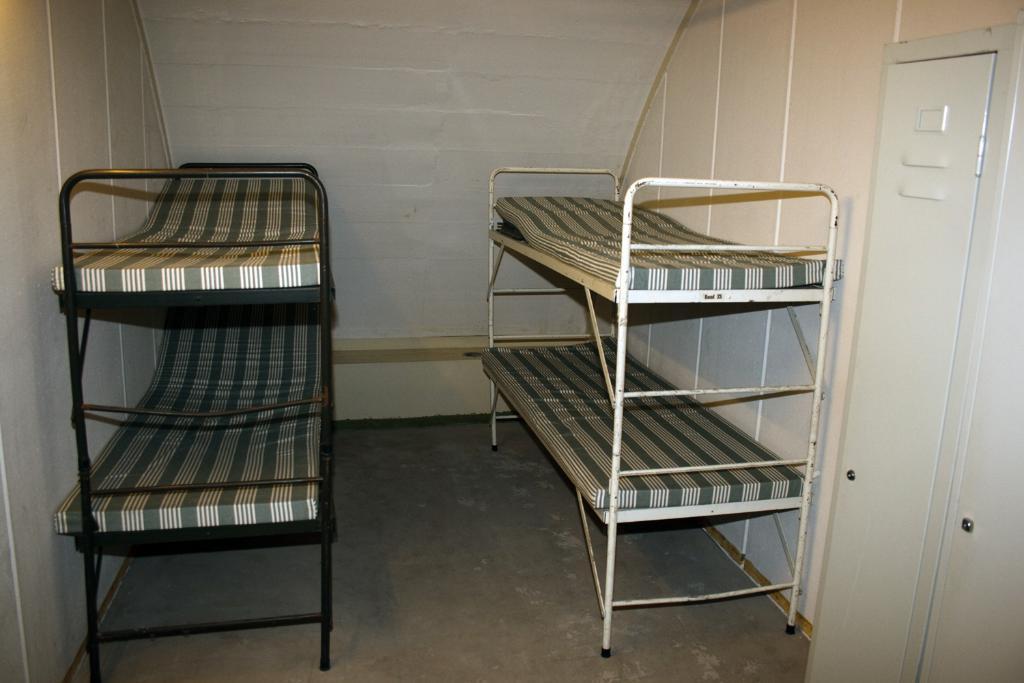Describe this image in one or two sentences. This picture is taken inside the room. In this image, on the right side, we can see a white color door and a bed. On the left side, we can also see another bed. At the top, we can see a roof. 